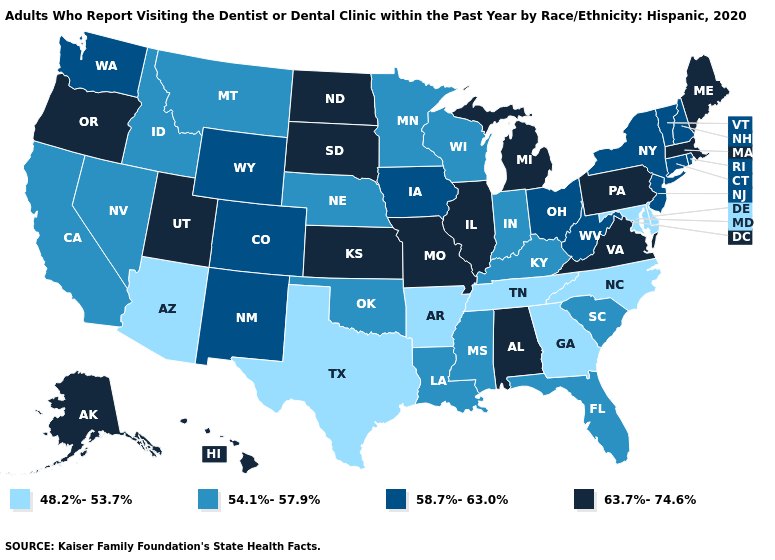Among the states that border Alabama , does Florida have the highest value?
Answer briefly. Yes. Is the legend a continuous bar?
Concise answer only. No. Among the states that border Montana , does Wyoming have the lowest value?
Keep it brief. No. Which states have the lowest value in the USA?
Quick response, please. Arizona, Arkansas, Delaware, Georgia, Maryland, North Carolina, Tennessee, Texas. What is the highest value in states that border Colorado?
Quick response, please. 63.7%-74.6%. Name the states that have a value in the range 48.2%-53.7%?
Answer briefly. Arizona, Arkansas, Delaware, Georgia, Maryland, North Carolina, Tennessee, Texas. What is the value of Wyoming?
Give a very brief answer. 58.7%-63.0%. Name the states that have a value in the range 63.7%-74.6%?
Write a very short answer. Alabama, Alaska, Hawaii, Illinois, Kansas, Maine, Massachusetts, Michigan, Missouri, North Dakota, Oregon, Pennsylvania, South Dakota, Utah, Virginia. Which states have the lowest value in the USA?
Short answer required. Arizona, Arkansas, Delaware, Georgia, Maryland, North Carolina, Tennessee, Texas. What is the lowest value in the Northeast?
Short answer required. 58.7%-63.0%. What is the lowest value in the South?
Be succinct. 48.2%-53.7%. Name the states that have a value in the range 63.7%-74.6%?
Quick response, please. Alabama, Alaska, Hawaii, Illinois, Kansas, Maine, Massachusetts, Michigan, Missouri, North Dakota, Oregon, Pennsylvania, South Dakota, Utah, Virginia. What is the value of Indiana?
Concise answer only. 54.1%-57.9%. Among the states that border California , does Oregon have the lowest value?
Concise answer only. No. What is the value of Tennessee?
Answer briefly. 48.2%-53.7%. 